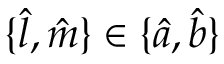Convert formula to latex. <formula><loc_0><loc_0><loc_500><loc_500>\{ \hat { l } , \hat { m } \} \in \{ \hat { a } , \hat { b } \}</formula> 